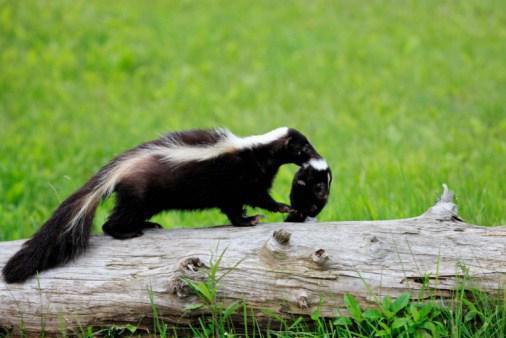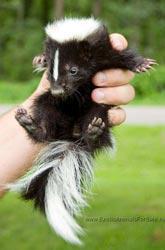The first image is the image on the left, the second image is the image on the right. Considering the images on both sides, is "An image shows a forward-facing row of at least three skunks with white stripes down their faces and tails standing up." valid? Answer yes or no. No. The first image is the image on the left, the second image is the image on the right. For the images displayed, is the sentence "At least one photo shows two or more skunks facing forward with their tails raised." factually correct? Answer yes or no. No. 